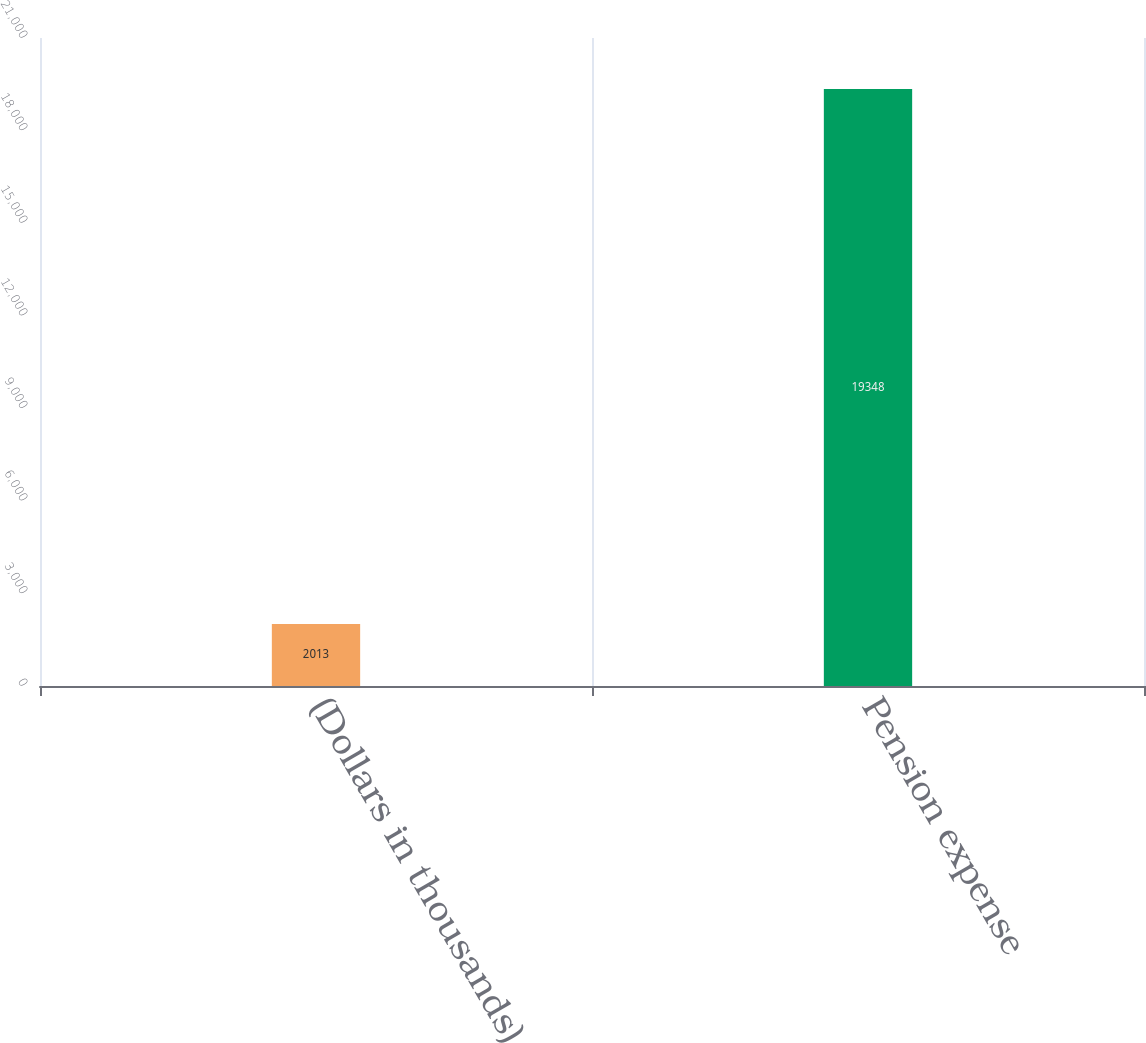Convert chart. <chart><loc_0><loc_0><loc_500><loc_500><bar_chart><fcel>(Dollars in thousands)<fcel>Pension expense<nl><fcel>2013<fcel>19348<nl></chart> 